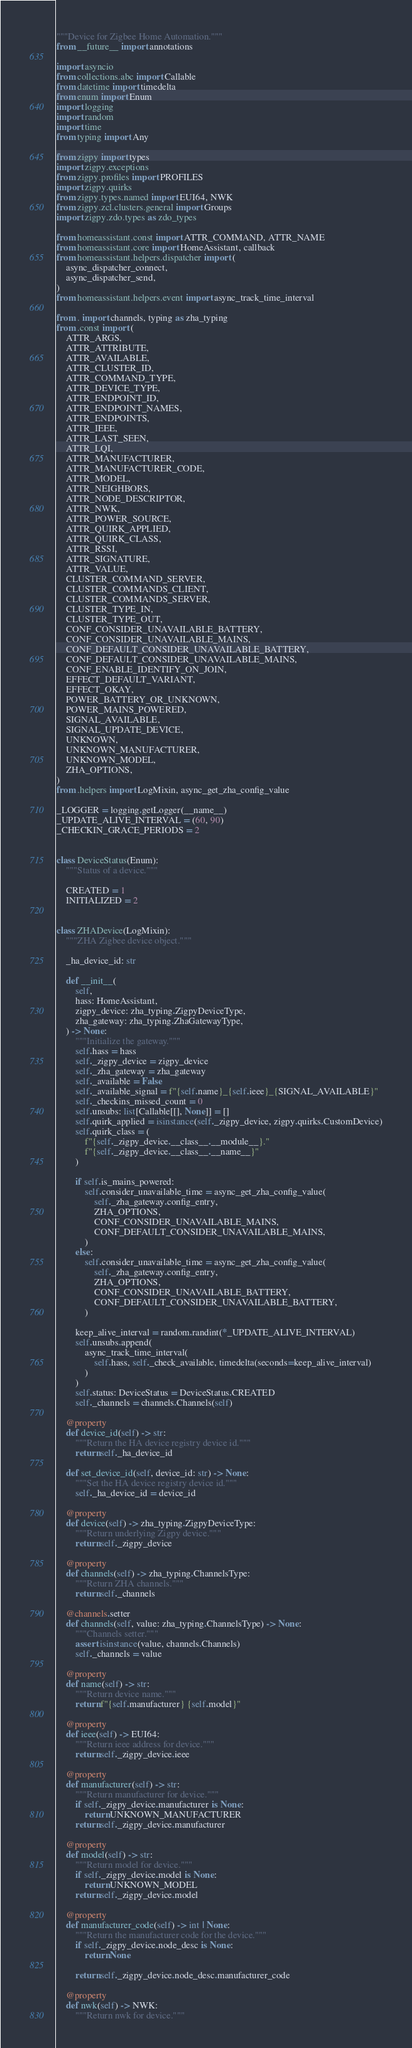Convert code to text. <code><loc_0><loc_0><loc_500><loc_500><_Python_>"""Device for Zigbee Home Automation."""
from __future__ import annotations

import asyncio
from collections.abc import Callable
from datetime import timedelta
from enum import Enum
import logging
import random
import time
from typing import Any

from zigpy import types
import zigpy.exceptions
from zigpy.profiles import PROFILES
import zigpy.quirks
from zigpy.types.named import EUI64, NWK
from zigpy.zcl.clusters.general import Groups
import zigpy.zdo.types as zdo_types

from homeassistant.const import ATTR_COMMAND, ATTR_NAME
from homeassistant.core import HomeAssistant, callback
from homeassistant.helpers.dispatcher import (
    async_dispatcher_connect,
    async_dispatcher_send,
)
from homeassistant.helpers.event import async_track_time_interval

from . import channels, typing as zha_typing
from .const import (
    ATTR_ARGS,
    ATTR_ATTRIBUTE,
    ATTR_AVAILABLE,
    ATTR_CLUSTER_ID,
    ATTR_COMMAND_TYPE,
    ATTR_DEVICE_TYPE,
    ATTR_ENDPOINT_ID,
    ATTR_ENDPOINT_NAMES,
    ATTR_ENDPOINTS,
    ATTR_IEEE,
    ATTR_LAST_SEEN,
    ATTR_LQI,
    ATTR_MANUFACTURER,
    ATTR_MANUFACTURER_CODE,
    ATTR_MODEL,
    ATTR_NEIGHBORS,
    ATTR_NODE_DESCRIPTOR,
    ATTR_NWK,
    ATTR_POWER_SOURCE,
    ATTR_QUIRK_APPLIED,
    ATTR_QUIRK_CLASS,
    ATTR_RSSI,
    ATTR_SIGNATURE,
    ATTR_VALUE,
    CLUSTER_COMMAND_SERVER,
    CLUSTER_COMMANDS_CLIENT,
    CLUSTER_COMMANDS_SERVER,
    CLUSTER_TYPE_IN,
    CLUSTER_TYPE_OUT,
    CONF_CONSIDER_UNAVAILABLE_BATTERY,
    CONF_CONSIDER_UNAVAILABLE_MAINS,
    CONF_DEFAULT_CONSIDER_UNAVAILABLE_BATTERY,
    CONF_DEFAULT_CONSIDER_UNAVAILABLE_MAINS,
    CONF_ENABLE_IDENTIFY_ON_JOIN,
    EFFECT_DEFAULT_VARIANT,
    EFFECT_OKAY,
    POWER_BATTERY_OR_UNKNOWN,
    POWER_MAINS_POWERED,
    SIGNAL_AVAILABLE,
    SIGNAL_UPDATE_DEVICE,
    UNKNOWN,
    UNKNOWN_MANUFACTURER,
    UNKNOWN_MODEL,
    ZHA_OPTIONS,
)
from .helpers import LogMixin, async_get_zha_config_value

_LOGGER = logging.getLogger(__name__)
_UPDATE_ALIVE_INTERVAL = (60, 90)
_CHECKIN_GRACE_PERIODS = 2


class DeviceStatus(Enum):
    """Status of a device."""

    CREATED = 1
    INITIALIZED = 2


class ZHADevice(LogMixin):
    """ZHA Zigbee device object."""

    _ha_device_id: str

    def __init__(
        self,
        hass: HomeAssistant,
        zigpy_device: zha_typing.ZigpyDeviceType,
        zha_gateway: zha_typing.ZhaGatewayType,
    ) -> None:
        """Initialize the gateway."""
        self.hass = hass
        self._zigpy_device = zigpy_device
        self._zha_gateway = zha_gateway
        self._available = False
        self._available_signal = f"{self.name}_{self.ieee}_{SIGNAL_AVAILABLE}"
        self._checkins_missed_count = 0
        self.unsubs: list[Callable[[], None]] = []
        self.quirk_applied = isinstance(self._zigpy_device, zigpy.quirks.CustomDevice)
        self.quirk_class = (
            f"{self._zigpy_device.__class__.__module__}."
            f"{self._zigpy_device.__class__.__name__}"
        )

        if self.is_mains_powered:
            self.consider_unavailable_time = async_get_zha_config_value(
                self._zha_gateway.config_entry,
                ZHA_OPTIONS,
                CONF_CONSIDER_UNAVAILABLE_MAINS,
                CONF_DEFAULT_CONSIDER_UNAVAILABLE_MAINS,
            )
        else:
            self.consider_unavailable_time = async_get_zha_config_value(
                self._zha_gateway.config_entry,
                ZHA_OPTIONS,
                CONF_CONSIDER_UNAVAILABLE_BATTERY,
                CONF_DEFAULT_CONSIDER_UNAVAILABLE_BATTERY,
            )

        keep_alive_interval = random.randint(*_UPDATE_ALIVE_INTERVAL)
        self.unsubs.append(
            async_track_time_interval(
                self.hass, self._check_available, timedelta(seconds=keep_alive_interval)
            )
        )
        self.status: DeviceStatus = DeviceStatus.CREATED
        self._channels = channels.Channels(self)

    @property
    def device_id(self) -> str:
        """Return the HA device registry device id."""
        return self._ha_device_id

    def set_device_id(self, device_id: str) -> None:
        """Set the HA device registry device id."""
        self._ha_device_id = device_id

    @property
    def device(self) -> zha_typing.ZigpyDeviceType:
        """Return underlying Zigpy device."""
        return self._zigpy_device

    @property
    def channels(self) -> zha_typing.ChannelsType:
        """Return ZHA channels."""
        return self._channels

    @channels.setter
    def channels(self, value: zha_typing.ChannelsType) -> None:
        """Channels setter."""
        assert isinstance(value, channels.Channels)
        self._channels = value

    @property
    def name(self) -> str:
        """Return device name."""
        return f"{self.manufacturer} {self.model}"

    @property
    def ieee(self) -> EUI64:
        """Return ieee address for device."""
        return self._zigpy_device.ieee

    @property
    def manufacturer(self) -> str:
        """Return manufacturer for device."""
        if self._zigpy_device.manufacturer is None:
            return UNKNOWN_MANUFACTURER
        return self._zigpy_device.manufacturer

    @property
    def model(self) -> str:
        """Return model for device."""
        if self._zigpy_device.model is None:
            return UNKNOWN_MODEL
        return self._zigpy_device.model

    @property
    def manufacturer_code(self) -> int | None:
        """Return the manufacturer code for the device."""
        if self._zigpy_device.node_desc is None:
            return None

        return self._zigpy_device.node_desc.manufacturer_code

    @property
    def nwk(self) -> NWK:
        """Return nwk for device."""</code> 